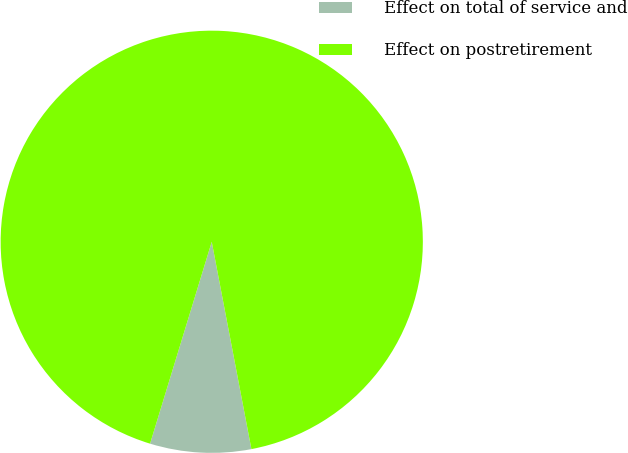Convert chart. <chart><loc_0><loc_0><loc_500><loc_500><pie_chart><fcel>Effect on total of service and<fcel>Effect on postretirement<nl><fcel>7.73%<fcel>92.27%<nl></chart> 